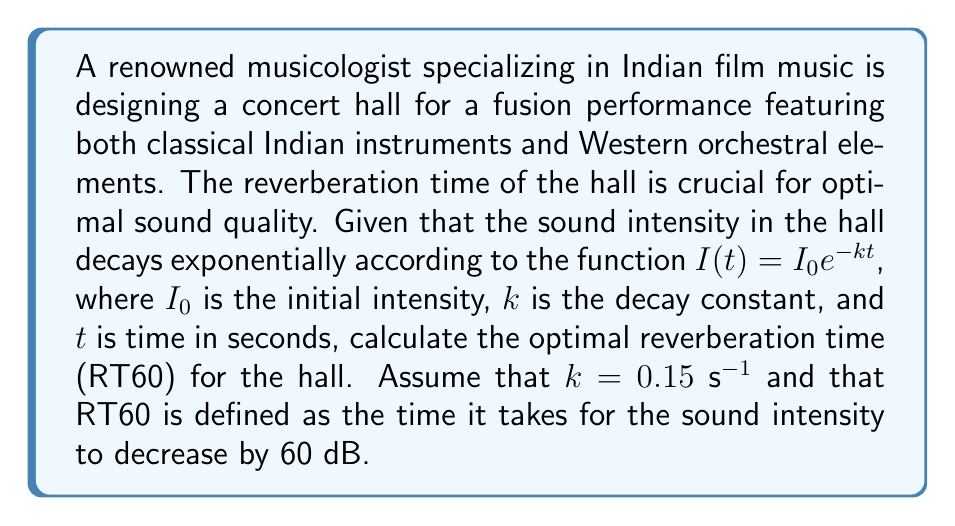Could you help me with this problem? To solve this problem, we need to follow these steps:

1) First, recall that the decibel (dB) is a logarithmic unit. A decrease of 60 dB means that the final intensity is $10^{-6}$ times the initial intensity.

2) We can express this mathematically as:

   $$\frac{I(t)}{I_0} = 10^{-6}$$

3) Substituting the given exponential decay function:

   $$\frac{I_0e^{-kt}}{I_0} = 10^{-6}$$

4) The $I_0$ terms cancel out:

   $$e^{-kt} = 10^{-6}$$

5) Taking the natural logarithm of both sides:

   $$-kt = \ln(10^{-6})$$

6) Using the logarithm property $\ln(a^b) = b\ln(a)$:

   $$-kt = -6\ln(10)$$

7) Solve for $t$:

   $$t = \frac{6\ln(10)}{k}$$

8) Now, substitute the given value of $k = 0.15$ s$^{-1}$:

   $$t = \frac{6\ln(10)}{0.15} \approx 92.1$$

Therefore, the optimal reverberation time (RT60) for the concert hall is approximately 92.1 seconds.
Answer: The optimal reverberation time (RT60) for the concert hall is approximately 92.1 seconds. 